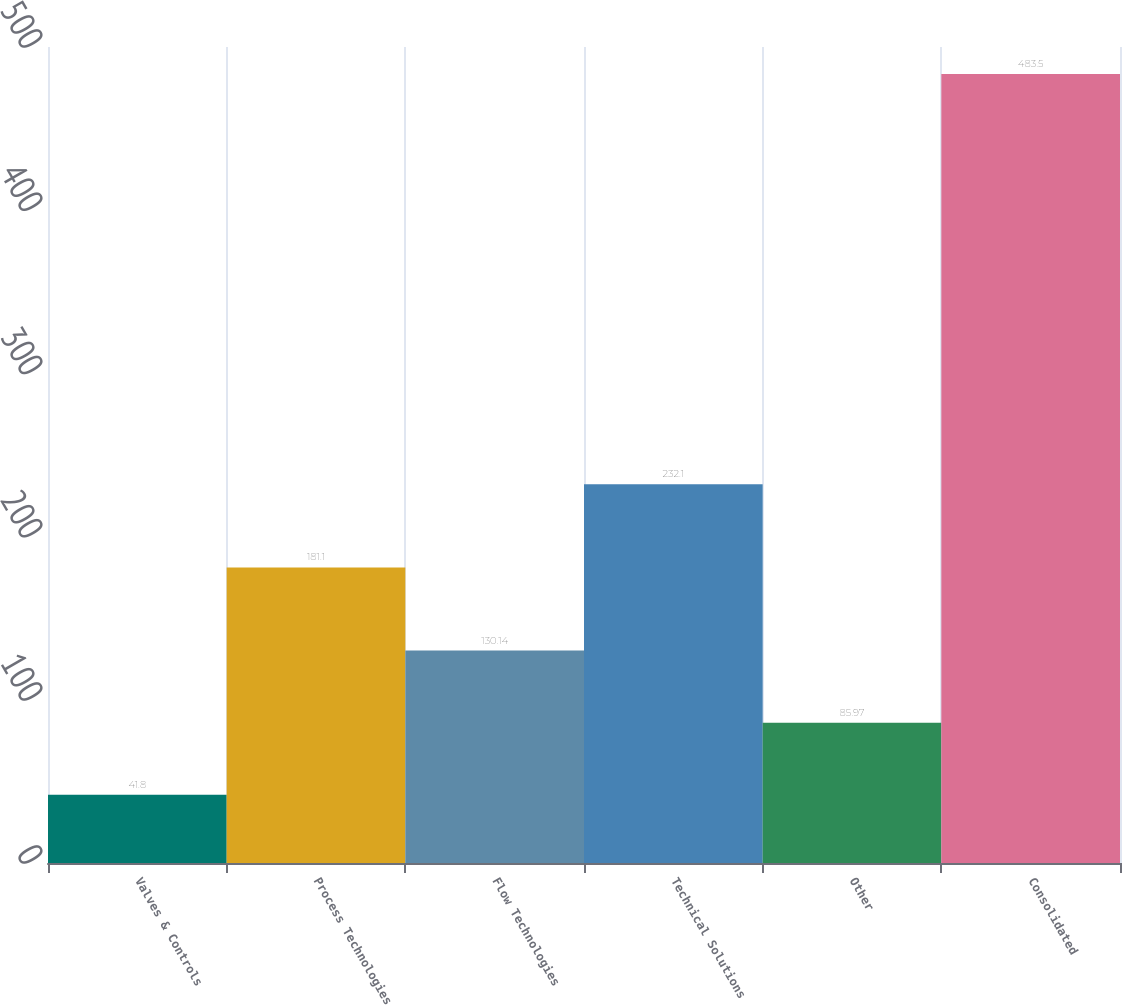Convert chart to OTSL. <chart><loc_0><loc_0><loc_500><loc_500><bar_chart><fcel>Valves & Controls<fcel>Process Technologies<fcel>Flow Technologies<fcel>Technical Solutions<fcel>Other<fcel>Consolidated<nl><fcel>41.8<fcel>181.1<fcel>130.14<fcel>232.1<fcel>85.97<fcel>483.5<nl></chart> 